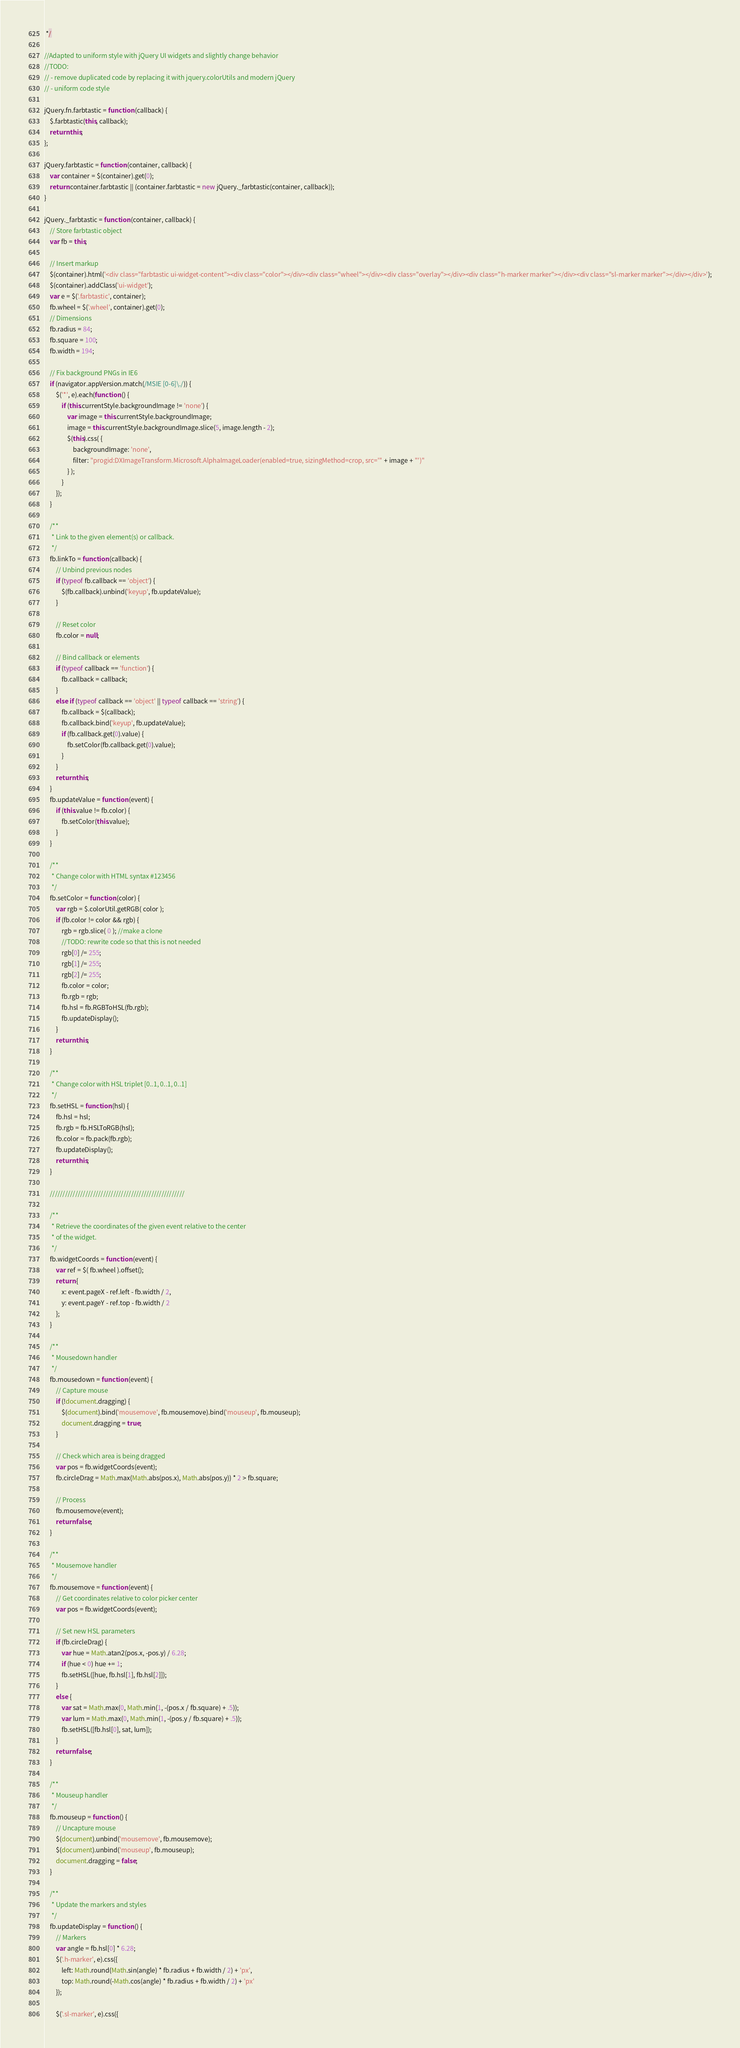<code> <loc_0><loc_0><loc_500><loc_500><_JavaScript_> */

//Adapted to uniform style with jQuery UI widgets and slightly change behavior
//TODO:
// - remove duplicated code by replacing it with jquery.colorUtils and modern jQuery
// - uniform code style

jQuery.fn.farbtastic = function (callback) {
	$.farbtastic(this, callback);
	return this;
};

jQuery.farbtastic = function (container, callback) {
	var container = $(container).get(0);
	return container.farbtastic || (container.farbtastic = new jQuery._farbtastic(container, callback));
}

jQuery._farbtastic = function (container, callback) {
	// Store farbtastic object
	var fb = this;

	// Insert markup
	$(container).html('<div class="farbtastic ui-widget-content"><div class="color"></div><div class="wheel"></div><div class="overlay"></div><div class="h-marker marker"></div><div class="sl-marker marker"></div></div>');
	$(container).addClass('ui-widget');
	var e = $('.farbtastic', container);
	fb.wheel = $('.wheel', container).get(0);
	// Dimensions
	fb.radius = 84;
	fb.square = 100;
	fb.width = 194;

	// Fix background PNGs in IE6
	if (navigator.appVersion.match(/MSIE [0-6]\./)) {
		$('*', e).each(function () {
			if (this.currentStyle.backgroundImage != 'none') {
				var image = this.currentStyle.backgroundImage;
				image = this.currentStyle.backgroundImage.slice(5, image.length - 2);
				$(this).css( {
					backgroundImage: 'none',
					filter: "progid:DXImageTransform.Microsoft.AlphaImageLoader(enabled=true, sizingMethod=crop, src='" + image + "')"
				} );
			}
		});
	}

	/**
	 * Link to the given element(s) or callback.
	 */
	fb.linkTo = function (callback) {
		// Unbind previous nodes
		if (typeof fb.callback == 'object') {
			$(fb.callback).unbind('keyup', fb.updateValue);
		}

		// Reset color
		fb.color = null;

		// Bind callback or elements
		if (typeof callback == 'function') {
			fb.callback = callback;
		}
		else if (typeof callback == 'object' || typeof callback == 'string') {
			fb.callback = $(callback);
			fb.callback.bind('keyup', fb.updateValue);
			if (fb.callback.get(0).value) {
				fb.setColor(fb.callback.get(0).value);
			}
		}
		return this;
	}
	fb.updateValue = function (event) {
		if (this.value != fb.color) {
			fb.setColor(this.value);
		}
	}

	/**
	 * Change color with HTML syntax #123456
	 */
	fb.setColor = function (color) {
		var rgb = $.colorUtil.getRGB( color );
		if (fb.color != color && rgb) {
			rgb = rgb.slice( 0 ); //make a clone
			//TODO: rewrite code so that this is not needed
			rgb[0] /= 255;
			rgb[1] /= 255;
			rgb[2] /= 255;
			fb.color = color;
			fb.rgb = rgb;
			fb.hsl = fb.RGBToHSL(fb.rgb);
			fb.updateDisplay();
		}
		return this;
	}

	/**
	 * Change color with HSL triplet [0..1, 0..1, 0..1]
	 */
	fb.setHSL = function (hsl) {
		fb.hsl = hsl;
		fb.rgb = fb.HSLToRGB(hsl);
		fb.color = fb.pack(fb.rgb);
		fb.updateDisplay();
		return this;
	}

	/////////////////////////////////////////////////////

	/**
	 * Retrieve the coordinates of the given event relative to the center
	 * of the widget.
	 */
	fb.widgetCoords = function (event) {
		var ref = $( fb.wheel ).offset();
		return {
			x: event.pageX - ref.left - fb.width / 2,
			y: event.pageY - ref.top - fb.width / 2
		};
	}

	/**
	 * Mousedown handler
	 */
	fb.mousedown = function (event) {
		// Capture mouse
		if (!document.dragging) {
			$(document).bind('mousemove', fb.mousemove).bind('mouseup', fb.mouseup);
			document.dragging = true;
		}

		// Check which area is being dragged
		var pos = fb.widgetCoords(event);
		fb.circleDrag = Math.max(Math.abs(pos.x), Math.abs(pos.y)) * 2 > fb.square;

		// Process
		fb.mousemove(event);
		return false;
	}

	/**
	 * Mousemove handler
	 */
	fb.mousemove = function (event) {
		// Get coordinates relative to color picker center
		var pos = fb.widgetCoords(event);

		// Set new HSL parameters
		if (fb.circleDrag) {
			var hue = Math.atan2(pos.x, -pos.y) / 6.28;
			if (hue < 0) hue += 1;
			fb.setHSL([hue, fb.hsl[1], fb.hsl[2]]);
		}
		else {
			var sat = Math.max(0, Math.min(1, -(pos.x / fb.square) + .5));
			var lum = Math.max(0, Math.min(1, -(pos.y / fb.square) + .5));
			fb.setHSL([fb.hsl[0], sat, lum]);
		}
		return false;
	}

	/**
	 * Mouseup handler
	 */
	fb.mouseup = function () {
		// Uncapture mouse
		$(document).unbind('mousemove', fb.mousemove);
		$(document).unbind('mouseup', fb.mouseup);
		document.dragging = false;
	}

	/**
	 * Update the markers and styles
	 */
	fb.updateDisplay = function () {
		// Markers
		var angle = fb.hsl[0] * 6.28;
		$('.h-marker', e).css({
			left: Math.round(Math.sin(angle) * fb.radius + fb.width / 2) + 'px',
			top: Math.round(-Math.cos(angle) * fb.radius + fb.width / 2) + 'px'
		});

		$('.sl-marker', e).css({</code> 